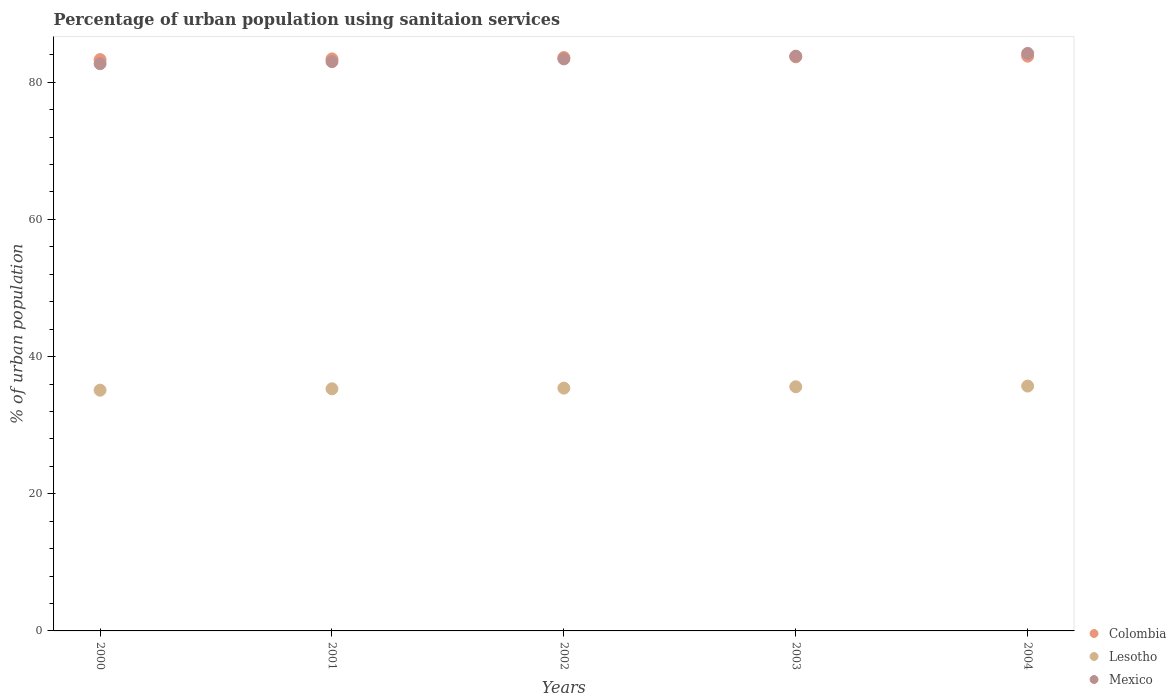What is the percentage of urban population using sanitaion services in Mexico in 2002?
Your answer should be very brief. 83.4. Across all years, what is the maximum percentage of urban population using sanitaion services in Lesotho?
Keep it short and to the point. 35.7. Across all years, what is the minimum percentage of urban population using sanitaion services in Lesotho?
Your answer should be compact. 35.1. In which year was the percentage of urban population using sanitaion services in Mexico maximum?
Your answer should be compact. 2004. What is the total percentage of urban population using sanitaion services in Mexico in the graph?
Provide a succinct answer. 417.1. What is the difference between the percentage of urban population using sanitaion services in Mexico in 2000 and that in 2001?
Give a very brief answer. -0.3. What is the difference between the percentage of urban population using sanitaion services in Lesotho in 2003 and the percentage of urban population using sanitaion services in Colombia in 2001?
Make the answer very short. -47.8. What is the average percentage of urban population using sanitaion services in Lesotho per year?
Offer a terse response. 35.42. In the year 2004, what is the difference between the percentage of urban population using sanitaion services in Lesotho and percentage of urban population using sanitaion services in Colombia?
Offer a terse response. -48.1. What is the ratio of the percentage of urban population using sanitaion services in Colombia in 2000 to that in 2004?
Make the answer very short. 0.99. Is the difference between the percentage of urban population using sanitaion services in Lesotho in 2003 and 2004 greater than the difference between the percentage of urban population using sanitaion services in Colombia in 2003 and 2004?
Offer a terse response. No. What is the difference between the highest and the second highest percentage of urban population using sanitaion services in Lesotho?
Keep it short and to the point. 0.1. What is the difference between the highest and the lowest percentage of urban population using sanitaion services in Colombia?
Give a very brief answer. 0.5. In how many years, is the percentage of urban population using sanitaion services in Lesotho greater than the average percentage of urban population using sanitaion services in Lesotho taken over all years?
Your response must be concise. 2. How many dotlines are there?
Provide a short and direct response. 3. Does the graph contain any zero values?
Your answer should be compact. No. Where does the legend appear in the graph?
Provide a short and direct response. Bottom right. How are the legend labels stacked?
Provide a succinct answer. Vertical. What is the title of the graph?
Keep it short and to the point. Percentage of urban population using sanitaion services. What is the label or title of the X-axis?
Ensure brevity in your answer.  Years. What is the label or title of the Y-axis?
Your response must be concise. % of urban population. What is the % of urban population in Colombia in 2000?
Keep it short and to the point. 83.3. What is the % of urban population in Lesotho in 2000?
Give a very brief answer. 35.1. What is the % of urban population in Mexico in 2000?
Make the answer very short. 82.7. What is the % of urban population in Colombia in 2001?
Offer a very short reply. 83.4. What is the % of urban population of Lesotho in 2001?
Offer a terse response. 35.3. What is the % of urban population in Mexico in 2001?
Your response must be concise. 83. What is the % of urban population of Colombia in 2002?
Provide a succinct answer. 83.6. What is the % of urban population of Lesotho in 2002?
Your answer should be very brief. 35.4. What is the % of urban population of Mexico in 2002?
Offer a very short reply. 83.4. What is the % of urban population of Colombia in 2003?
Keep it short and to the point. 83.7. What is the % of urban population in Lesotho in 2003?
Give a very brief answer. 35.6. What is the % of urban population in Mexico in 2003?
Your answer should be very brief. 83.8. What is the % of urban population of Colombia in 2004?
Keep it short and to the point. 83.8. What is the % of urban population of Lesotho in 2004?
Make the answer very short. 35.7. What is the % of urban population in Mexico in 2004?
Make the answer very short. 84.2. Across all years, what is the maximum % of urban population of Colombia?
Offer a terse response. 83.8. Across all years, what is the maximum % of urban population in Lesotho?
Your response must be concise. 35.7. Across all years, what is the maximum % of urban population in Mexico?
Your answer should be compact. 84.2. Across all years, what is the minimum % of urban population in Colombia?
Keep it short and to the point. 83.3. Across all years, what is the minimum % of urban population in Lesotho?
Give a very brief answer. 35.1. Across all years, what is the minimum % of urban population in Mexico?
Your answer should be very brief. 82.7. What is the total % of urban population of Colombia in the graph?
Offer a very short reply. 417.8. What is the total % of urban population in Lesotho in the graph?
Provide a succinct answer. 177.1. What is the total % of urban population of Mexico in the graph?
Keep it short and to the point. 417.1. What is the difference between the % of urban population of Colombia in 2000 and that in 2001?
Offer a terse response. -0.1. What is the difference between the % of urban population of Mexico in 2000 and that in 2001?
Your response must be concise. -0.3. What is the difference between the % of urban population in Lesotho in 2000 and that in 2002?
Make the answer very short. -0.3. What is the difference between the % of urban population of Mexico in 2000 and that in 2002?
Your answer should be very brief. -0.7. What is the difference between the % of urban population in Lesotho in 2000 and that in 2003?
Your answer should be compact. -0.5. What is the difference between the % of urban population in Mexico in 2000 and that in 2003?
Ensure brevity in your answer.  -1.1. What is the difference between the % of urban population in Colombia in 2000 and that in 2004?
Ensure brevity in your answer.  -0.5. What is the difference between the % of urban population of Lesotho in 2000 and that in 2004?
Provide a short and direct response. -0.6. What is the difference between the % of urban population in Mexico in 2000 and that in 2004?
Your response must be concise. -1.5. What is the difference between the % of urban population of Colombia in 2001 and that in 2002?
Give a very brief answer. -0.2. What is the difference between the % of urban population in Lesotho in 2001 and that in 2002?
Provide a succinct answer. -0.1. What is the difference between the % of urban population of Lesotho in 2003 and that in 2004?
Your answer should be very brief. -0.1. What is the difference between the % of urban population in Lesotho in 2000 and the % of urban population in Mexico in 2001?
Offer a very short reply. -47.9. What is the difference between the % of urban population in Colombia in 2000 and the % of urban population in Lesotho in 2002?
Ensure brevity in your answer.  47.9. What is the difference between the % of urban population in Colombia in 2000 and the % of urban population in Mexico in 2002?
Your answer should be compact. -0.1. What is the difference between the % of urban population of Lesotho in 2000 and the % of urban population of Mexico in 2002?
Provide a short and direct response. -48.3. What is the difference between the % of urban population of Colombia in 2000 and the % of urban population of Lesotho in 2003?
Your answer should be compact. 47.7. What is the difference between the % of urban population in Lesotho in 2000 and the % of urban population in Mexico in 2003?
Provide a succinct answer. -48.7. What is the difference between the % of urban population in Colombia in 2000 and the % of urban population in Lesotho in 2004?
Provide a short and direct response. 47.6. What is the difference between the % of urban population in Lesotho in 2000 and the % of urban population in Mexico in 2004?
Make the answer very short. -49.1. What is the difference between the % of urban population in Lesotho in 2001 and the % of urban population in Mexico in 2002?
Your answer should be compact. -48.1. What is the difference between the % of urban population in Colombia in 2001 and the % of urban population in Lesotho in 2003?
Your answer should be compact. 47.8. What is the difference between the % of urban population of Lesotho in 2001 and the % of urban population of Mexico in 2003?
Your answer should be very brief. -48.5. What is the difference between the % of urban population in Colombia in 2001 and the % of urban population in Lesotho in 2004?
Ensure brevity in your answer.  47.7. What is the difference between the % of urban population in Colombia in 2001 and the % of urban population in Mexico in 2004?
Give a very brief answer. -0.8. What is the difference between the % of urban population in Lesotho in 2001 and the % of urban population in Mexico in 2004?
Provide a succinct answer. -48.9. What is the difference between the % of urban population of Colombia in 2002 and the % of urban population of Mexico in 2003?
Your answer should be compact. -0.2. What is the difference between the % of urban population in Lesotho in 2002 and the % of urban population in Mexico in 2003?
Give a very brief answer. -48.4. What is the difference between the % of urban population of Colombia in 2002 and the % of urban population of Lesotho in 2004?
Offer a very short reply. 47.9. What is the difference between the % of urban population of Lesotho in 2002 and the % of urban population of Mexico in 2004?
Your response must be concise. -48.8. What is the difference between the % of urban population in Lesotho in 2003 and the % of urban population in Mexico in 2004?
Ensure brevity in your answer.  -48.6. What is the average % of urban population in Colombia per year?
Offer a terse response. 83.56. What is the average % of urban population in Lesotho per year?
Provide a succinct answer. 35.42. What is the average % of urban population in Mexico per year?
Provide a succinct answer. 83.42. In the year 2000, what is the difference between the % of urban population of Colombia and % of urban population of Lesotho?
Your response must be concise. 48.2. In the year 2000, what is the difference between the % of urban population in Colombia and % of urban population in Mexico?
Offer a terse response. 0.6. In the year 2000, what is the difference between the % of urban population in Lesotho and % of urban population in Mexico?
Make the answer very short. -47.6. In the year 2001, what is the difference between the % of urban population in Colombia and % of urban population in Lesotho?
Ensure brevity in your answer.  48.1. In the year 2001, what is the difference between the % of urban population in Lesotho and % of urban population in Mexico?
Provide a short and direct response. -47.7. In the year 2002, what is the difference between the % of urban population of Colombia and % of urban population of Lesotho?
Offer a very short reply. 48.2. In the year 2002, what is the difference between the % of urban population in Colombia and % of urban population in Mexico?
Provide a succinct answer. 0.2. In the year 2002, what is the difference between the % of urban population of Lesotho and % of urban population of Mexico?
Give a very brief answer. -48. In the year 2003, what is the difference between the % of urban population in Colombia and % of urban population in Lesotho?
Provide a succinct answer. 48.1. In the year 2003, what is the difference between the % of urban population in Colombia and % of urban population in Mexico?
Make the answer very short. -0.1. In the year 2003, what is the difference between the % of urban population in Lesotho and % of urban population in Mexico?
Offer a very short reply. -48.2. In the year 2004, what is the difference between the % of urban population in Colombia and % of urban population in Lesotho?
Ensure brevity in your answer.  48.1. In the year 2004, what is the difference between the % of urban population of Colombia and % of urban population of Mexico?
Your response must be concise. -0.4. In the year 2004, what is the difference between the % of urban population in Lesotho and % of urban population in Mexico?
Your answer should be compact. -48.5. What is the ratio of the % of urban population of Lesotho in 2000 to that in 2001?
Offer a terse response. 0.99. What is the ratio of the % of urban population in Mexico in 2000 to that in 2001?
Provide a short and direct response. 1. What is the ratio of the % of urban population in Colombia in 2000 to that in 2002?
Your response must be concise. 1. What is the ratio of the % of urban population in Lesotho in 2000 to that in 2002?
Provide a short and direct response. 0.99. What is the ratio of the % of urban population of Mexico in 2000 to that in 2002?
Your answer should be compact. 0.99. What is the ratio of the % of urban population of Mexico in 2000 to that in 2003?
Your answer should be compact. 0.99. What is the ratio of the % of urban population in Lesotho in 2000 to that in 2004?
Your response must be concise. 0.98. What is the ratio of the % of urban population of Mexico in 2000 to that in 2004?
Ensure brevity in your answer.  0.98. What is the ratio of the % of urban population of Lesotho in 2001 to that in 2002?
Make the answer very short. 1. What is the ratio of the % of urban population of Lesotho in 2001 to that in 2003?
Provide a short and direct response. 0.99. What is the ratio of the % of urban population in Mexico in 2001 to that in 2003?
Make the answer very short. 0.99. What is the ratio of the % of urban population in Colombia in 2001 to that in 2004?
Your response must be concise. 1. What is the ratio of the % of urban population in Lesotho in 2001 to that in 2004?
Provide a succinct answer. 0.99. What is the ratio of the % of urban population in Mexico in 2001 to that in 2004?
Provide a short and direct response. 0.99. What is the ratio of the % of urban population of Mexico in 2002 to that in 2003?
Your response must be concise. 1. What is the ratio of the % of urban population in Lesotho in 2002 to that in 2004?
Provide a succinct answer. 0.99. What is the ratio of the % of urban population in Colombia in 2003 to that in 2004?
Make the answer very short. 1. What is the ratio of the % of urban population in Lesotho in 2003 to that in 2004?
Give a very brief answer. 1. What is the ratio of the % of urban population of Mexico in 2003 to that in 2004?
Offer a terse response. 1. What is the difference between the highest and the second highest % of urban population in Mexico?
Provide a short and direct response. 0.4. What is the difference between the highest and the lowest % of urban population in Lesotho?
Your answer should be very brief. 0.6. 